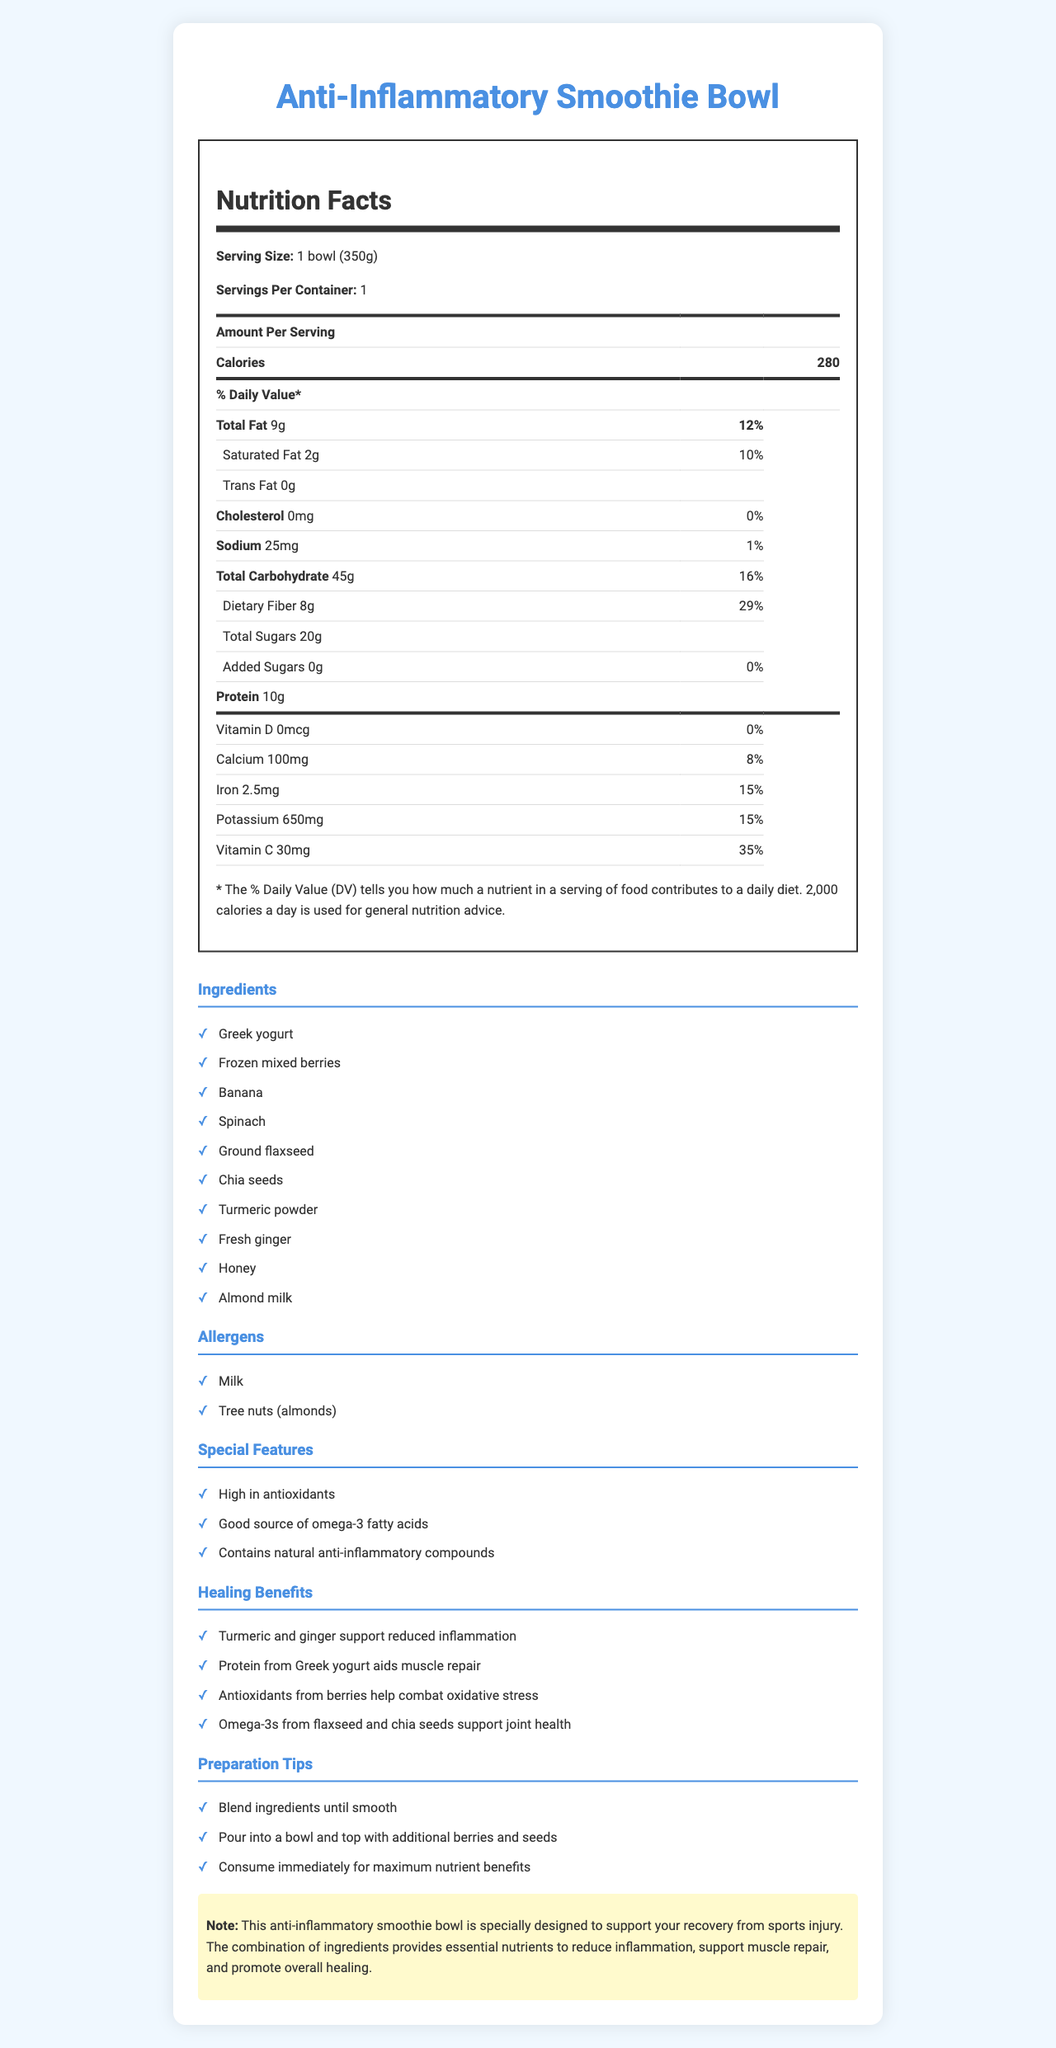what is the serving size of the anti-inflammatory smoothie bowl? The serving size is mentioned at the top of the nutrition label as "1 bowl (350g)".
Answer: 1 bowl (350g) how many calories are in one serving of the smoothie bowl? The number of calories per serving is stated right below the "Amount Per Serving" in the nutrition label.
Answer: 280 what is the total amount of dietary fiber in the smoothie bowl? The total dietary fiber is listed under "Total Carbohydrate" with an amount of 8g.
Answer: 8g what percentage of daily calcium does this smoothie bowl provide? The percentage of daily calcium value is given as "8%" on the nutrition label.
Answer: 8% how much protein is in one serving of the smoothie bowl? The amount of protein is clearly specified as "10g".
Answer: 10g which of the following ingredients is not included in the smoothie bowl? A. Greek yogurt B. Blueberries C. Honey D. Spinach The ingredients list includes Greek yogurt, honey, and spinach but does not specifically mention blueberries. Instead, it mentions mixed berries.
Answer: B. Blueberries which nutrient does not contribute to the daily value percentage? A. Vitamin D B. Iron C. Sodium D. Cholesterol Vitamin D has a daily value percentage of 0%, while Iron (15%), Sodium (1%), and Cholesterol (0%) all contribute some percentage to the daily value.
Answer: A. Vitamin D is the smoothie bowl high in antioxidants? The "Special Features" section mentions that the smoothie bowl is "High in antioxidants".
Answer: Yes what are the special features of the smoothie bowl? The special features are listed under the "Special Features" section.
Answer: High in antioxidants, Good source of omega-3 fatty acids, Contains natural anti-inflammatory compounds describe the main idea of the document. The document aims to guide the reader through the nutritional benefits and preparation of a smoothie bowl designed to reduce inflammation and aid healing from sports injuries.
Answer: The document provides a detailed nutrition facts label, ingredients, allergens, special features, healing benefits, and preparation tips for an anti-inflammatory smoothie bowl. It highlights the nutritional content, supports recovery from sports injuries with its anti-inflammatory compounds, and offers beneficial nutrients like antioxidants, omega-3s, and proteins. how many servings are there per container? The number of servings per container is explicitly mentioned as "1".
Answer: 1 what ingredient supports muscle repair according to the healing benefits? The "Healing Benefits" section states that protein from Greek yogurt aids muscle repair.
Answer: Greek yogurt does the smoothie bowl contain any added sugars? The nutrition label indicates that there are 0g of added sugars in the smoothie bowl.
Answer: No how should you consume the smoothie bowl for maximum nutrient benefits? Under the "Preparation Tips", it advises to "Consume immediately for maximum nutrient benefits".
Answer: Consume immediately what is the exact amount of sodium per serving? The nutrition label states the amount of sodium as "25mg".
Answer: 25mg what are the allergens present in the smoothie bowl? The "Allergens" section lists "Milk" and "Tree nuts (almonds)".
Answer: Milk, Tree nuts (almonds) does this document tell you the exact composition of mixed berries used? The document mentions "Frozen mixed berries" as an ingredient but does not specify the types or exact composition of the berries used.
Answer: Not enough information 